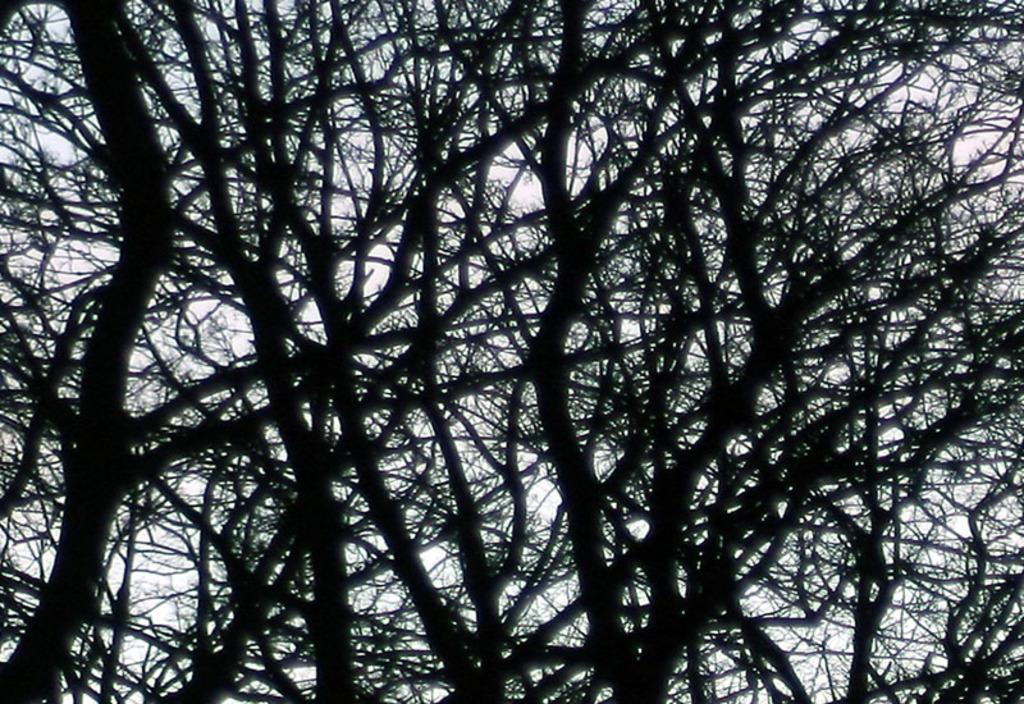What is in the foreground of the image? There are branches of trees in the foreground of the image. What is the condition of the branches? The branches do not have leaves. What can be seen through the gaps in the branches? The sky is visible through the gaps in the branches. What type of skin condition can be seen on the branches in the image? There is no skin condition present on the branches in the image, as branches are part of trees and do not have skin. 